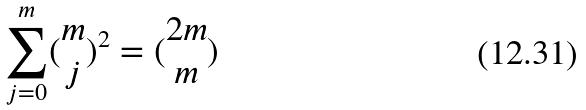Convert formula to latex. <formula><loc_0><loc_0><loc_500><loc_500>\sum _ { j = 0 } ^ { m } ( \begin{matrix} m \\ j \end{matrix} ) ^ { 2 } = ( \begin{matrix} 2 m \\ m \end{matrix} )</formula> 